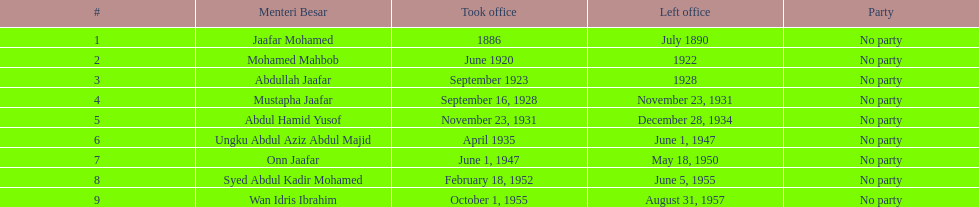What was the date the last person on the list left office? August 31, 1957. 